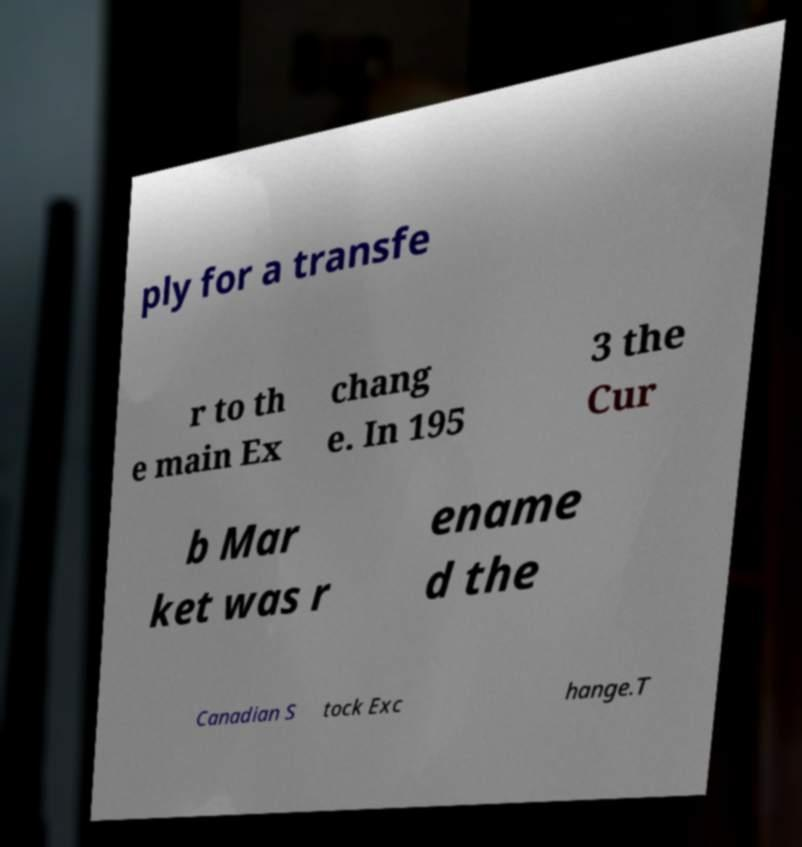For documentation purposes, I need the text within this image transcribed. Could you provide that? ply for a transfe r to th e main Ex chang e. In 195 3 the Cur b Mar ket was r ename d the Canadian S tock Exc hange.T 